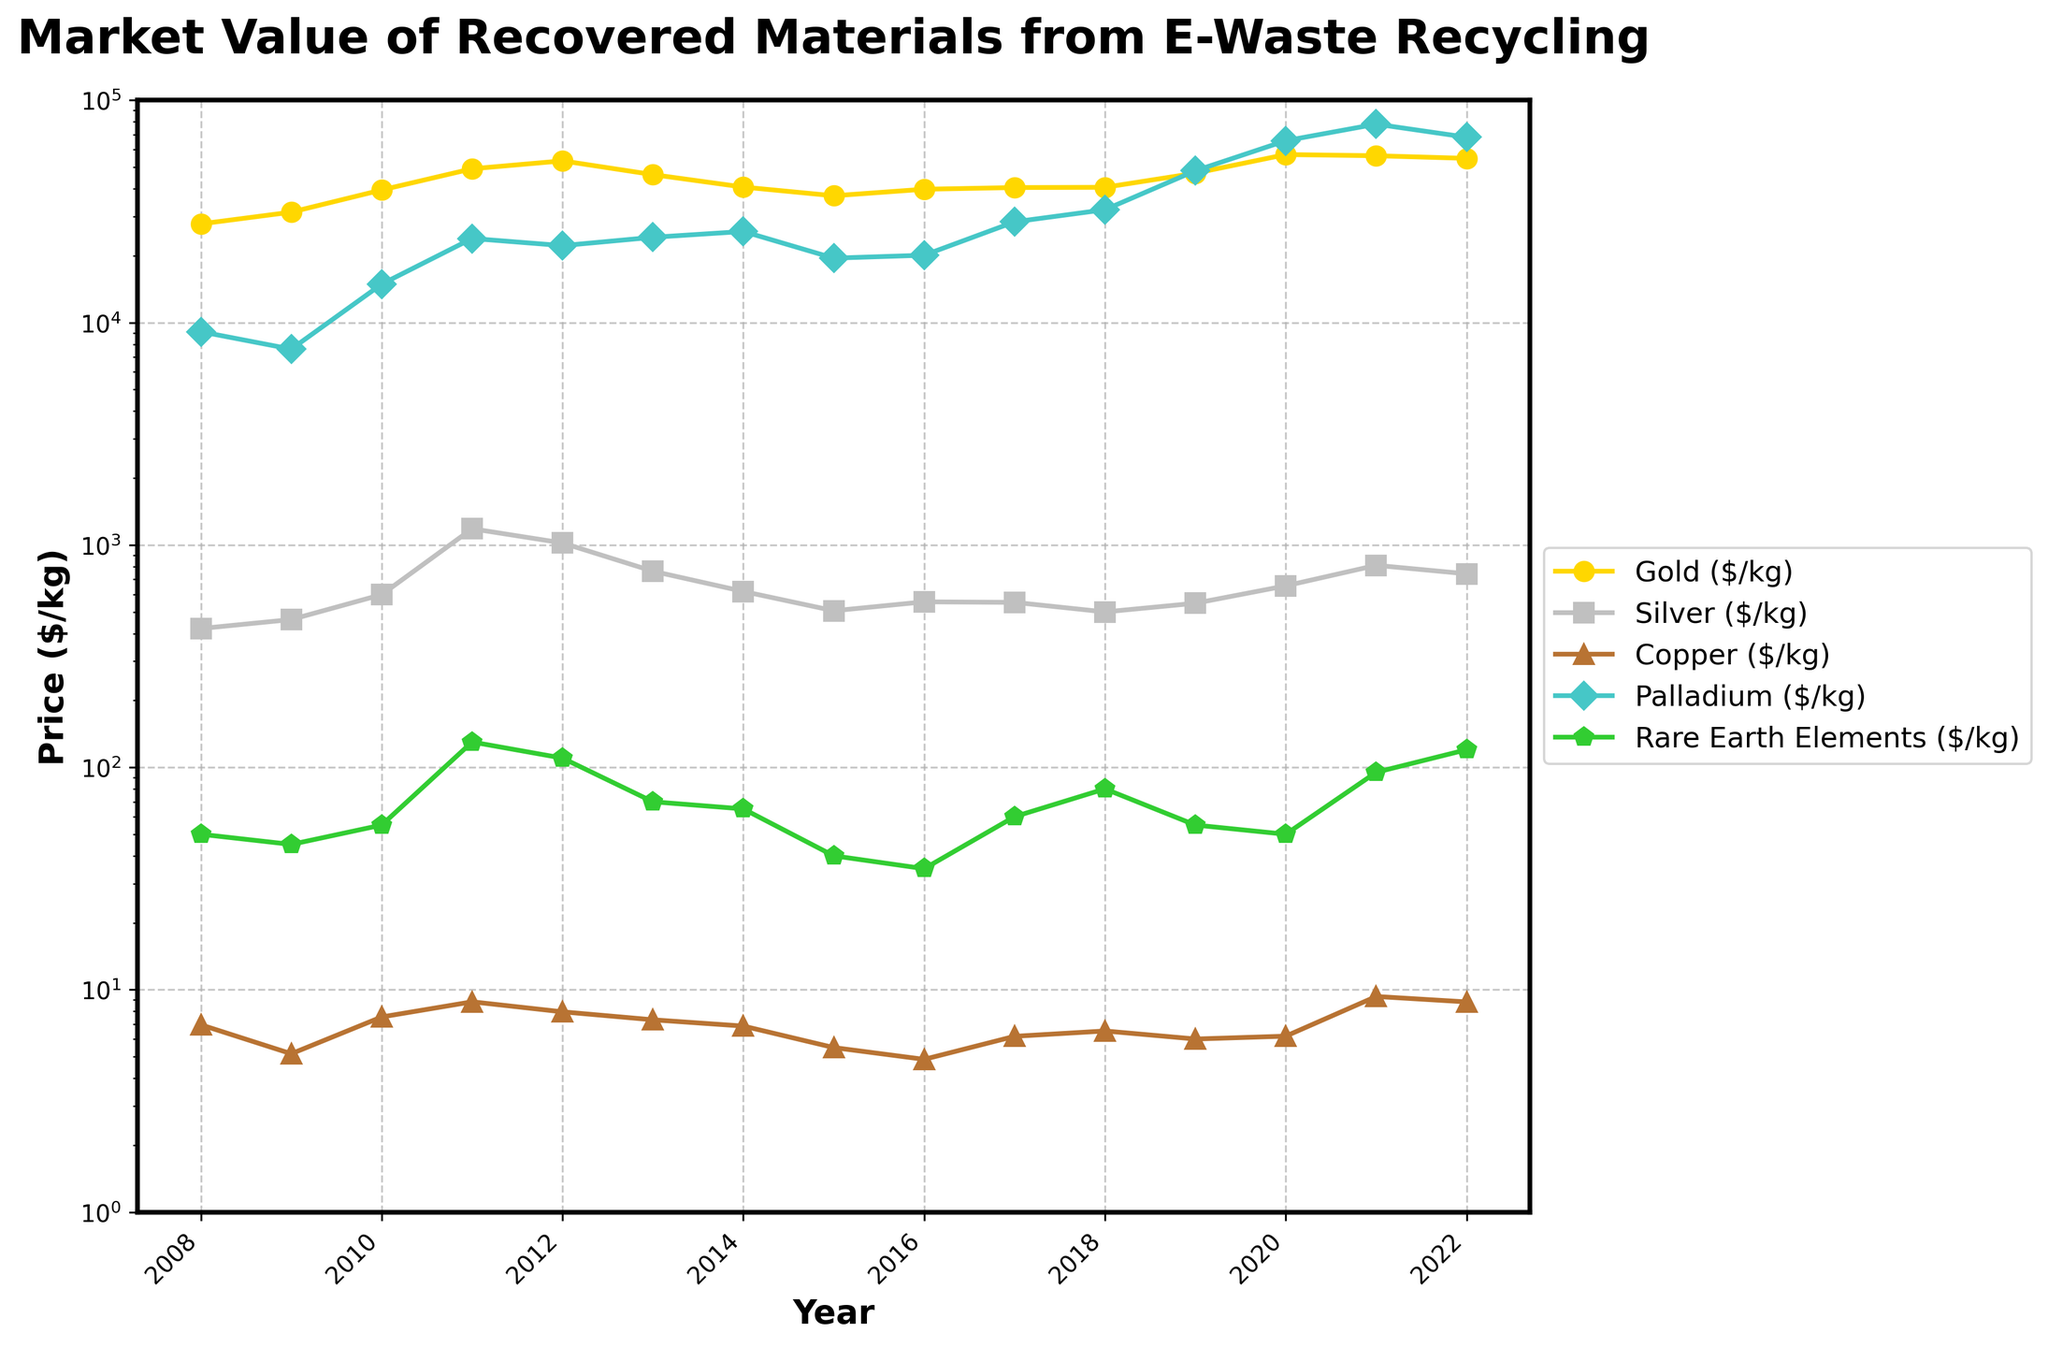What year had the highest market value for gold? By looking at the line representing gold (marked with circles), identify the peak point on the graph. The highest point is in the year 2020, with a value of $57,000/kg.
Answer: 2020 Which material had the most stable prices over the 15-year period? By visually inspecting the fluctuation patterns of each line, copper (orange line marked with triangles) remains relatively stable compared to others, showing lesser variance in values.
Answer: Copper In which year did palladium's market value exceed $50,000/kg for the first time? Trace the line representing palladium (purple line marked with diamonds). The year when it first goes above the $50,000/kg mark is 2019.
Answer: 2019 How does the market value of rare earth elements in 2022 compare to 2010? Look for the values of rare earth elements (green line marked with pentagons) in both years; 2022 has a value of $120/kg, and 2010 has a value of $55/kg. Comparison gives 120 - 55 = 65.
Answer: 65 What's the highest fluctuation observed for silver over the years? Identify the highest and lowest points for the yellow line marked by squares. The highest value for silver is $1,183/kg in 2011, and the lowest is $421/kg in 2008. Fluctuation = 1183 - 421 = 762.
Answer: 762 Which material had a sudden spike in market value in 2017? Examine the chart for any material that shows a sharp increase in 2017. The palladium line shows a significant rise from 2016 ($20,100/kg) to 2017 ($28,400/kg), an increase of 8,300.
Answer: Palladium Calculate the average market value for gold over the first 5 years. Add gold prices from 2008 to 2012 and divide by 5. Sum = 27,800 + 31,400 + 39,500 + 49,200 + 53,400 = 201,300. Average = 201,300 / 5 = 40,260.
Answer: 40,260 Which year did rare earth elements have the lowest market value? Trace the green line marked with pentagons to find the minimum point. The lowest value occurs in 2016 at $35/kg.
Answer: 2016 Which material saw the greatest overall increase in market value from 2008 to 2022? Calculate the difference between the end value and start value for each material. The greatest difference is for palladium, from $9,100/kg in 2008 to $68,200/kg in 2022, an increase of 59,100.
Answer: Palladium Did any material's price drop between 2021 and 2022? Compare the prices for each material between these years. Silver's price dropped from $810/kg in 2021 to $742/kg in 2022.
Answer: Silver 